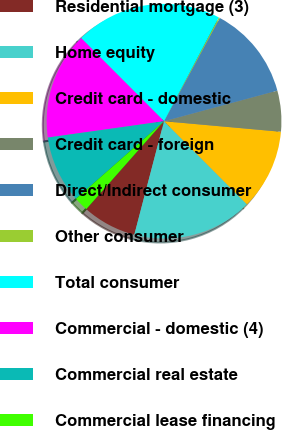Convert chart. <chart><loc_0><loc_0><loc_500><loc_500><pie_chart><fcel>Residential mortgage (3)<fcel>Home equity<fcel>Credit card - domestic<fcel>Credit card - foreign<fcel>Direct/Indirect consumer<fcel>Other consumer<fcel>Total consumer<fcel>Commercial - domestic (4)<fcel>Commercial real estate<fcel>Commercial lease financing<nl><fcel>7.45%<fcel>16.56%<fcel>11.09%<fcel>5.63%<fcel>12.92%<fcel>0.16%<fcel>20.2%<fcel>14.74%<fcel>9.27%<fcel>1.98%<nl></chart> 